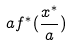<formula> <loc_0><loc_0><loc_500><loc_500>a f ^ { * } ( \frac { x ^ { * } } { a } )</formula> 